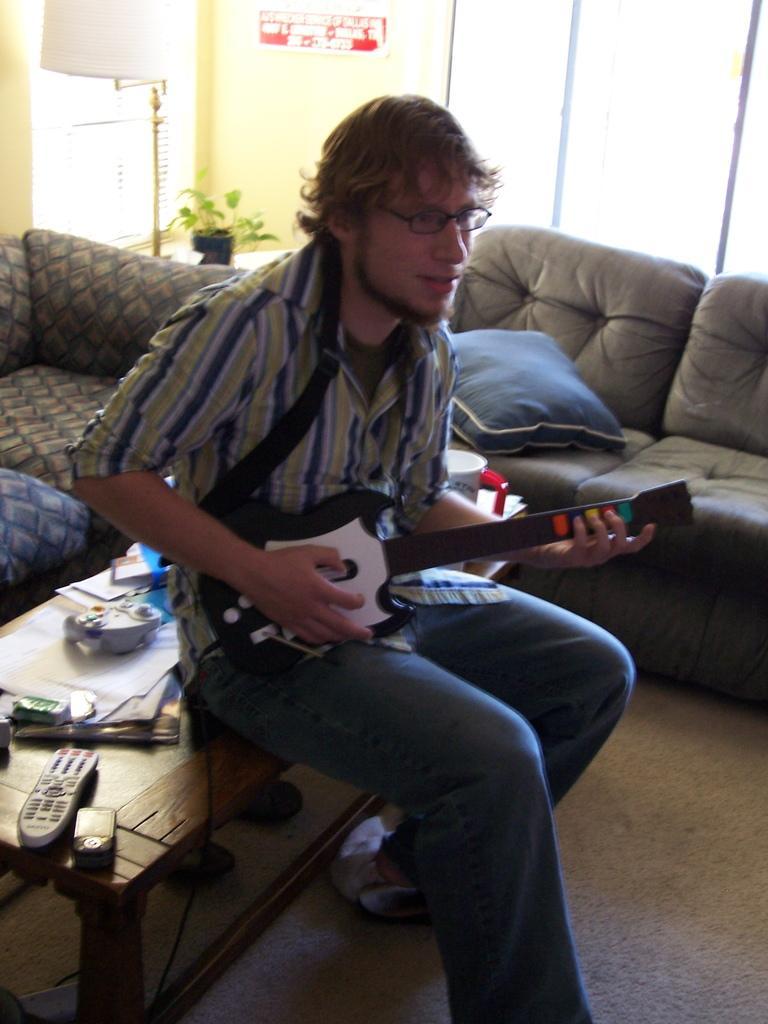Can you describe this image briefly? In this image there is a person sitting on a table and playing a musical instrument, there are objects on the table, there is a couch truncated towards the right of the image, there is a couch truncated towards the left of the image, there are objects truncated towards the left of the image, there is a pillow on the couch, there is a plant, there is an object truncated towards the top of the image, there is wall truncated towards the top of the image, there is a board on the wall, there is text on the board, there are windows truncated towards the top of the image, there is a mat truncated towards the bottom of the image, there are objects on the mat. 